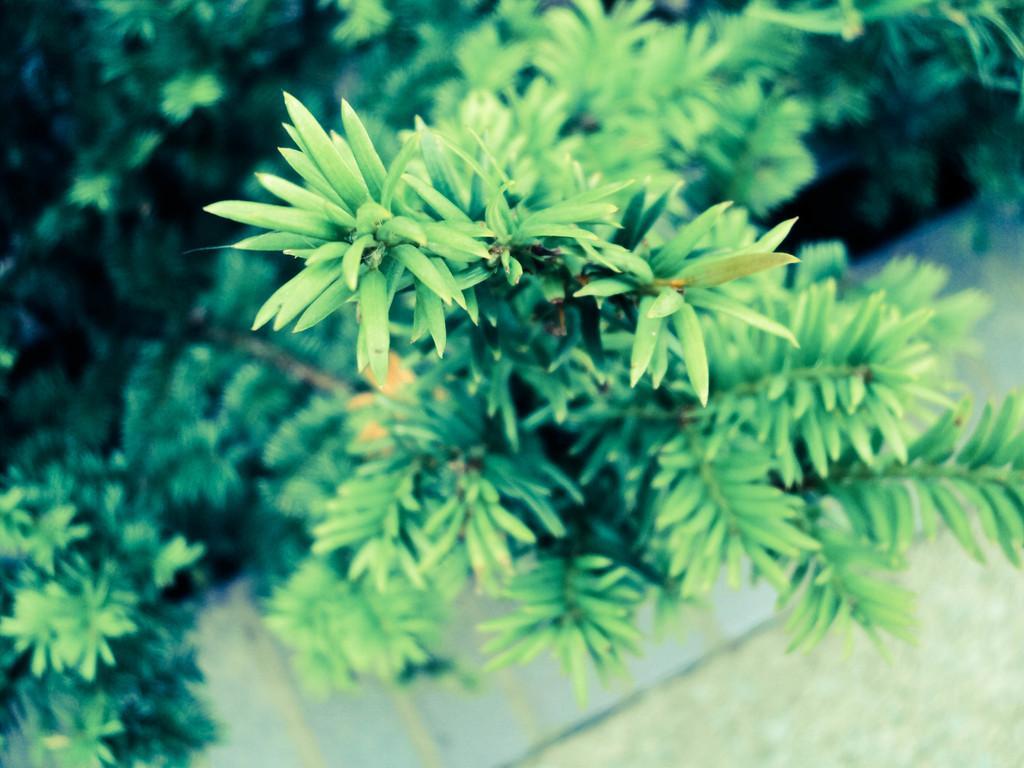Could you give a brief overview of what you see in this image? In this image I can see trees in green color. 